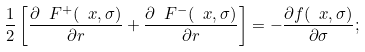Convert formula to latex. <formula><loc_0><loc_0><loc_500><loc_500>\frac { 1 } { 2 } \left [ \frac { \partial \ F ^ { + } ( \ x , \sigma ) } { \partial r } + \frac { \partial \ F ^ { - } ( \ x , \sigma ) } { \partial r } \right ] = - \frac { \partial f ( \ x , \sigma ) } { \partial \sigma } ;</formula> 